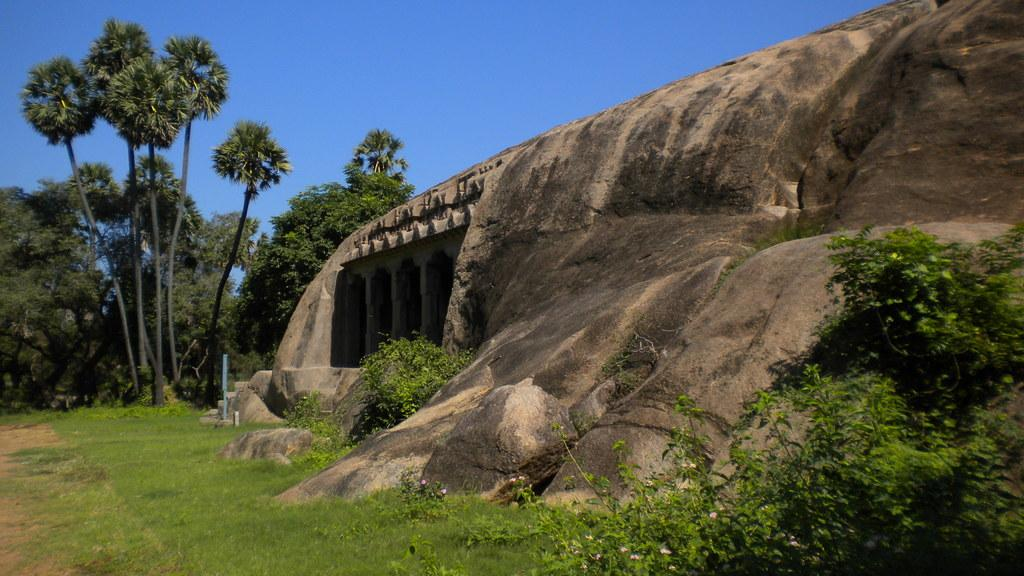What can be found on the right side of the image? There is a rock on the right side of the image. What type of architecture is depicted in the middle of the image? There is medieval architecture in the middle of the image. What is located on the left side of the image? There are trees on the left side of the image. What is visible at the top of the image? The sky is visible at the top of the image. What time of day is it in the image, specifically in the afternoon? The time of day is not specified in the image, and there is no indication of the afternoon. Can you see a zebra in the image? No, there is no zebra present in the image. 